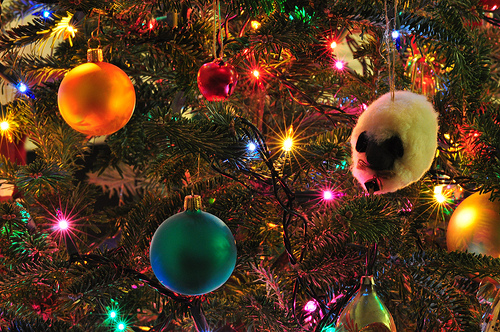<image>
Is there a light behind the tree? No. The light is not behind the tree. From this viewpoint, the light appears to be positioned elsewhere in the scene. 